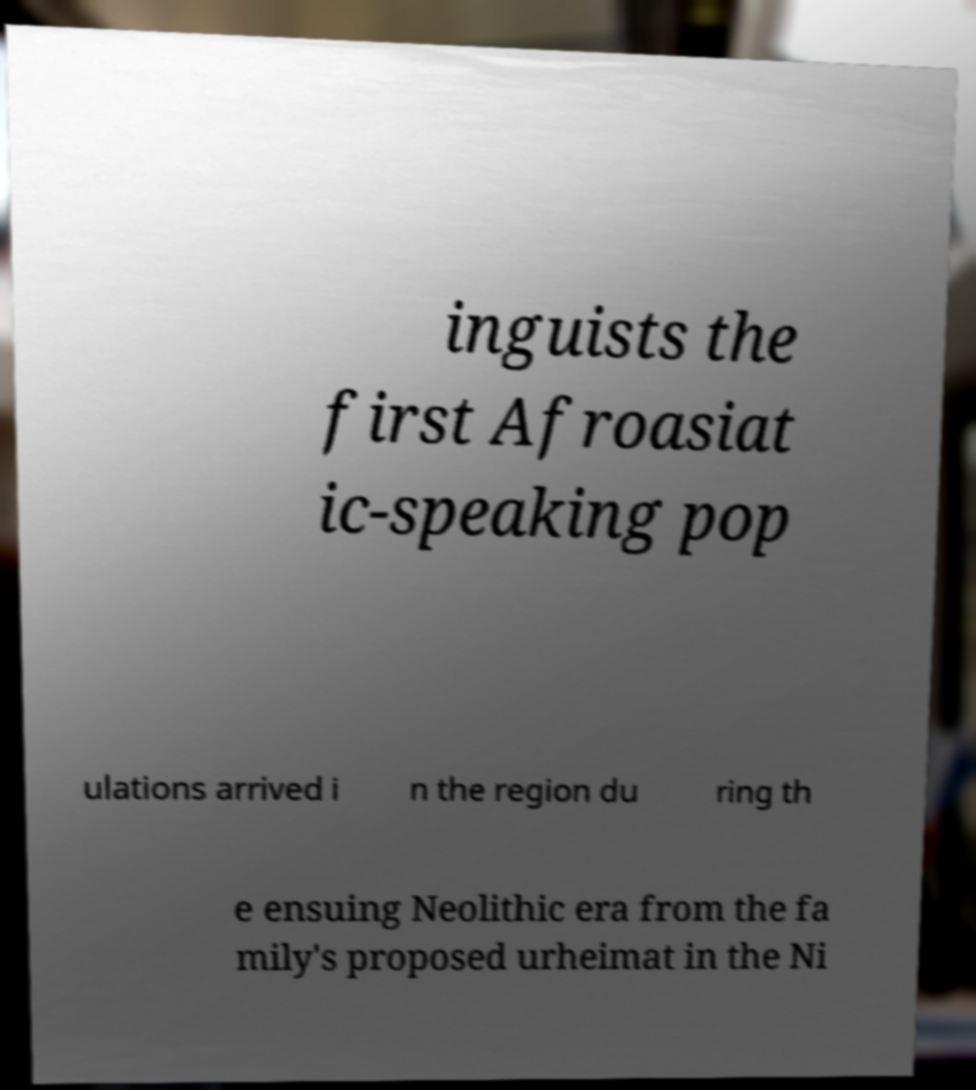For documentation purposes, I need the text within this image transcribed. Could you provide that? inguists the first Afroasiat ic-speaking pop ulations arrived i n the region du ring th e ensuing Neolithic era from the fa mily's proposed urheimat in the Ni 